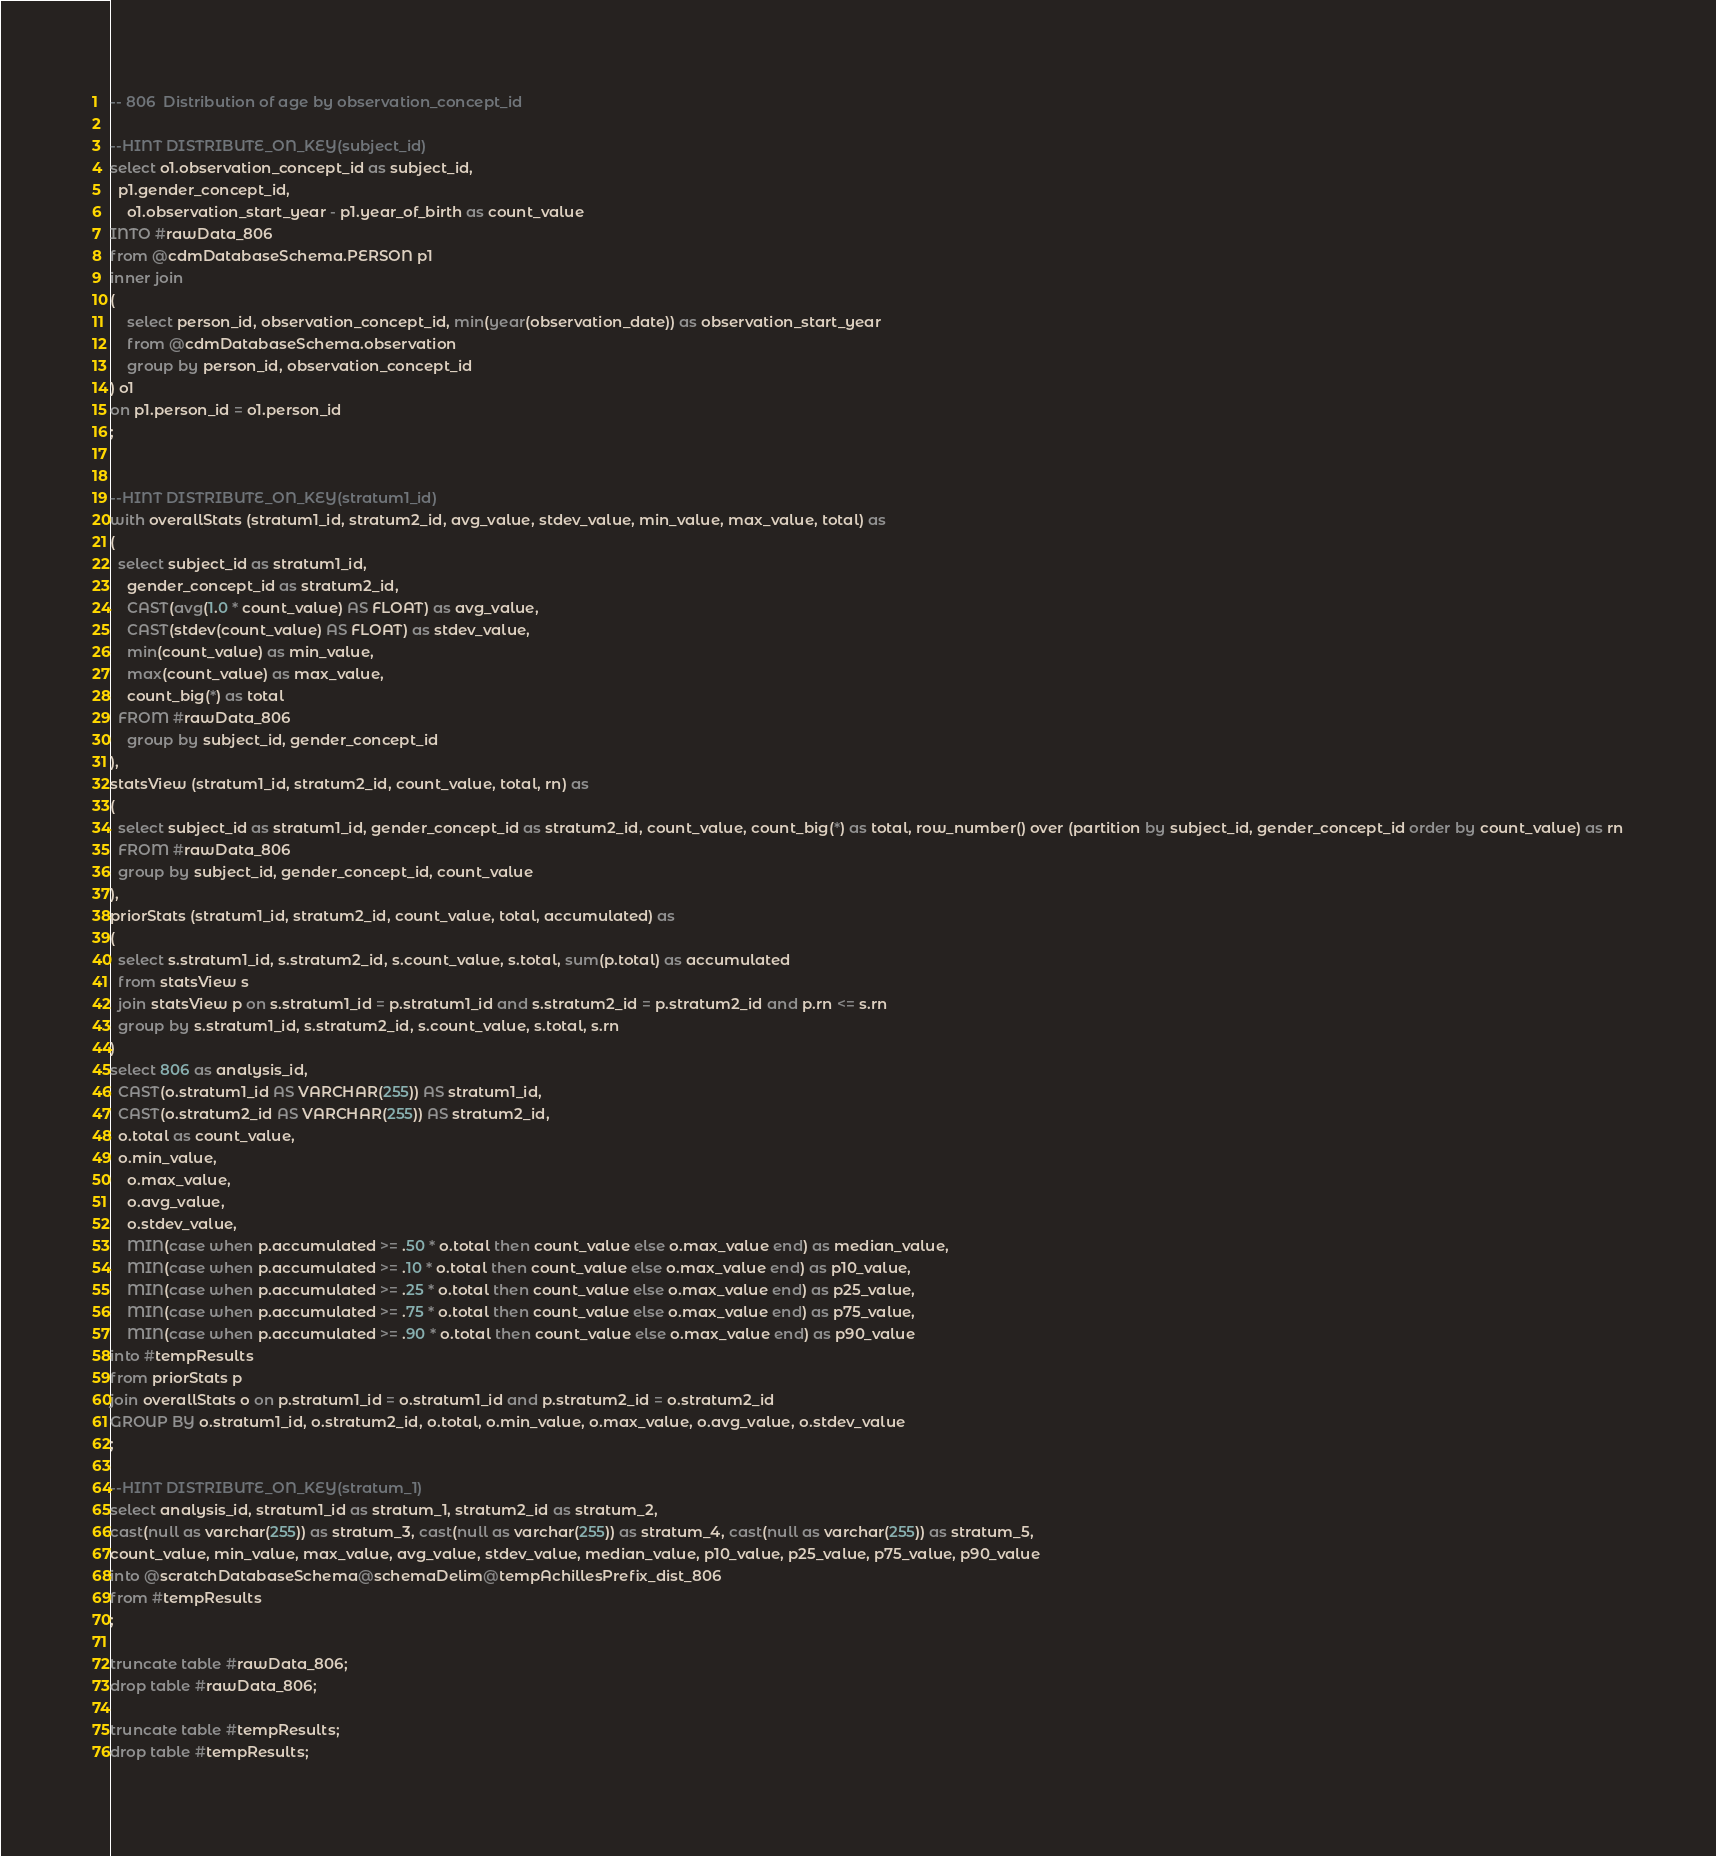<code> <loc_0><loc_0><loc_500><loc_500><_SQL_>-- 806	Distribution of age by observation_concept_id

--HINT DISTRIBUTE_ON_KEY(subject_id)
select o1.observation_concept_id as subject_id,
  p1.gender_concept_id,
	o1.observation_start_year - p1.year_of_birth as count_value
INTO #rawData_806
from @cdmDatabaseSchema.PERSON p1
inner join
(
	select person_id, observation_concept_id, min(year(observation_date)) as observation_start_year
	from @cdmDatabaseSchema.observation
	group by person_id, observation_concept_id
) o1
on p1.person_id = o1.person_id
;


--HINT DISTRIBUTE_ON_KEY(stratum1_id)
with overallStats (stratum1_id, stratum2_id, avg_value, stdev_value, min_value, max_value, total) as
(
  select subject_id as stratum1_id,
    gender_concept_id as stratum2_id,
    CAST(avg(1.0 * count_value) AS FLOAT) as avg_value,
    CAST(stdev(count_value) AS FLOAT) as stdev_value,
    min(count_value) as min_value,
    max(count_value) as max_value,
    count_big(*) as total
  FROM #rawData_806
	group by subject_id, gender_concept_id
),
statsView (stratum1_id, stratum2_id, count_value, total, rn) as
(
  select subject_id as stratum1_id, gender_concept_id as stratum2_id, count_value, count_big(*) as total, row_number() over (partition by subject_id, gender_concept_id order by count_value) as rn
  FROM #rawData_806
  group by subject_id, gender_concept_id, count_value
),
priorStats (stratum1_id, stratum2_id, count_value, total, accumulated) as
(
  select s.stratum1_id, s.stratum2_id, s.count_value, s.total, sum(p.total) as accumulated
  from statsView s
  join statsView p on s.stratum1_id = p.stratum1_id and s.stratum2_id = p.stratum2_id and p.rn <= s.rn
  group by s.stratum1_id, s.stratum2_id, s.count_value, s.total, s.rn
)
select 806 as analysis_id,
  CAST(o.stratum1_id AS VARCHAR(255)) AS stratum1_id,
  CAST(o.stratum2_id AS VARCHAR(255)) AS stratum2_id,
  o.total as count_value,
  o.min_value,
	o.max_value,
	o.avg_value,
	o.stdev_value,
	MIN(case when p.accumulated >= .50 * o.total then count_value else o.max_value end) as median_value,
	MIN(case when p.accumulated >= .10 * o.total then count_value else o.max_value end) as p10_value,
	MIN(case when p.accumulated >= .25 * o.total then count_value else o.max_value end) as p25_value,
	MIN(case when p.accumulated >= .75 * o.total then count_value else o.max_value end) as p75_value,
	MIN(case when p.accumulated >= .90 * o.total then count_value else o.max_value end) as p90_value
into #tempResults
from priorStats p
join overallStats o on p.stratum1_id = o.stratum1_id and p.stratum2_id = o.stratum2_id 
GROUP BY o.stratum1_id, o.stratum2_id, o.total, o.min_value, o.max_value, o.avg_value, o.stdev_value
;

--HINT DISTRIBUTE_ON_KEY(stratum_1)
select analysis_id, stratum1_id as stratum_1, stratum2_id as stratum_2, 
cast(null as varchar(255)) as stratum_3, cast(null as varchar(255)) as stratum_4, cast(null as varchar(255)) as stratum_5,
count_value, min_value, max_value, avg_value, stdev_value, median_value, p10_value, p25_value, p75_value, p90_value
into @scratchDatabaseSchema@schemaDelim@tempAchillesPrefix_dist_806
from #tempResults
;

truncate table #rawData_806;
drop table #rawData_806;

truncate table #tempResults;
drop table #tempResults;
</code> 